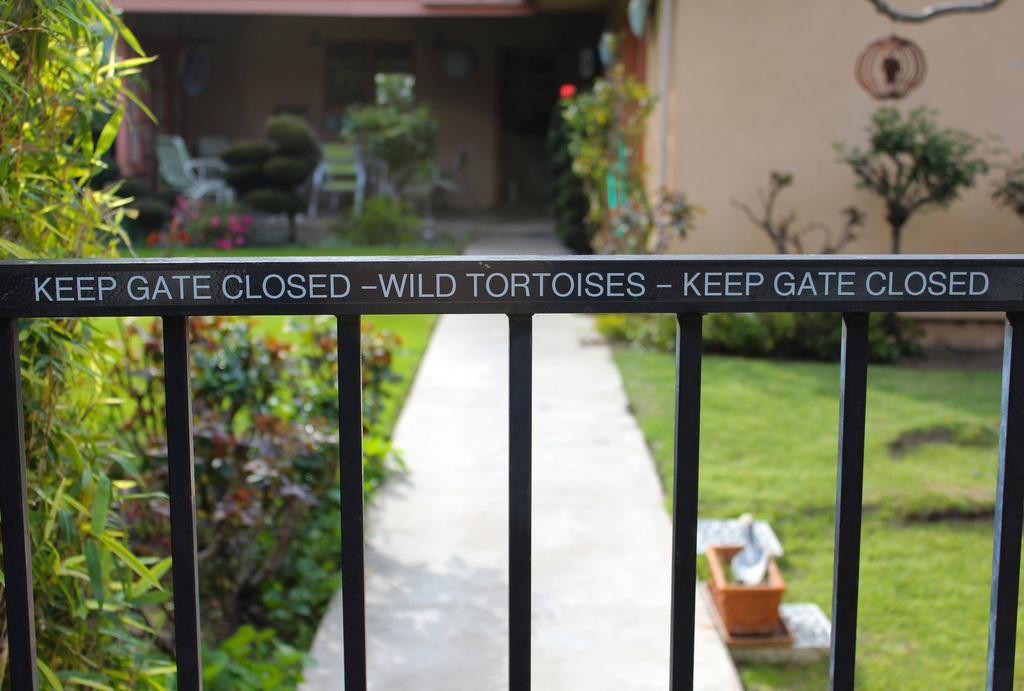What type of structure is in the image? There is a building in the image. What can be seen in front of the building? Trees, flower pots, a gate, a wall, and plants are visible in front of the building. Can you describe the landscaping in front of the building? The landscaping includes trees, flower pots, and plants. What might be the purpose of the gate in front of the building? The gate may serve as an entrance or boundary for the building. What type of soup is being served in the flower pots in the image? There is no soup present in the image; the flower pots contain plants. 